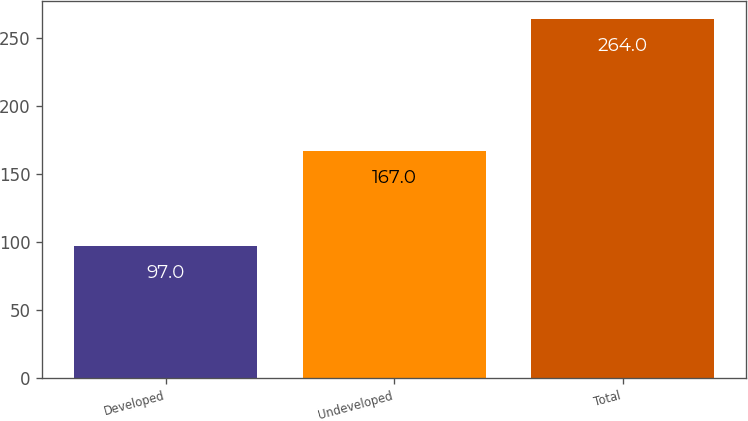Convert chart. <chart><loc_0><loc_0><loc_500><loc_500><bar_chart><fcel>Developed<fcel>Undeveloped<fcel>Total<nl><fcel>97<fcel>167<fcel>264<nl></chart> 